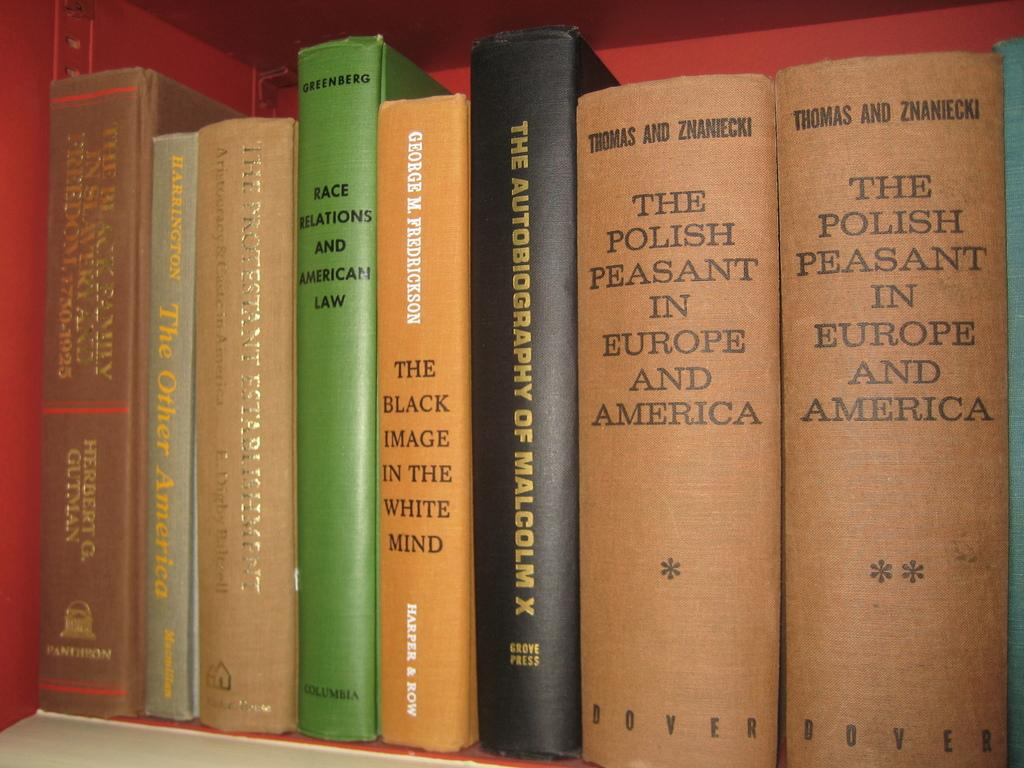<image>
Create a compact narrative representing the image presented. A set of books, two of which are about 'The Polish Peasant in Europe and America' 